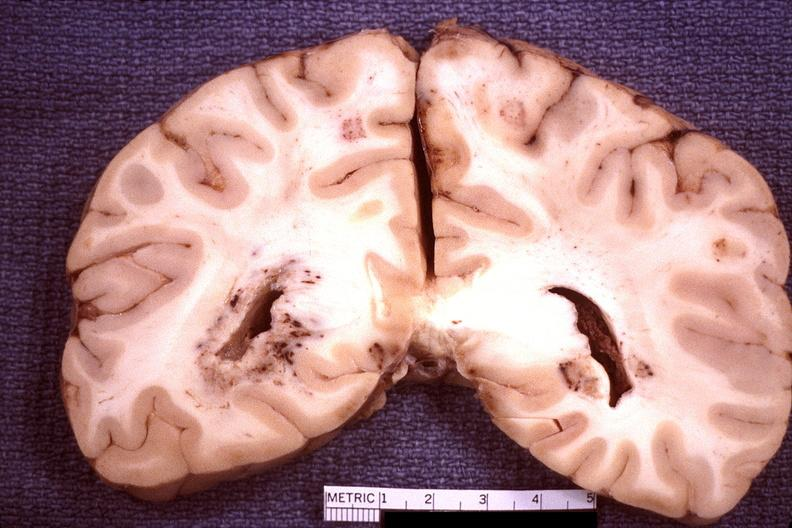does this image show brain, toxoplasma encephalitis?
Answer the question using a single word or phrase. Yes 